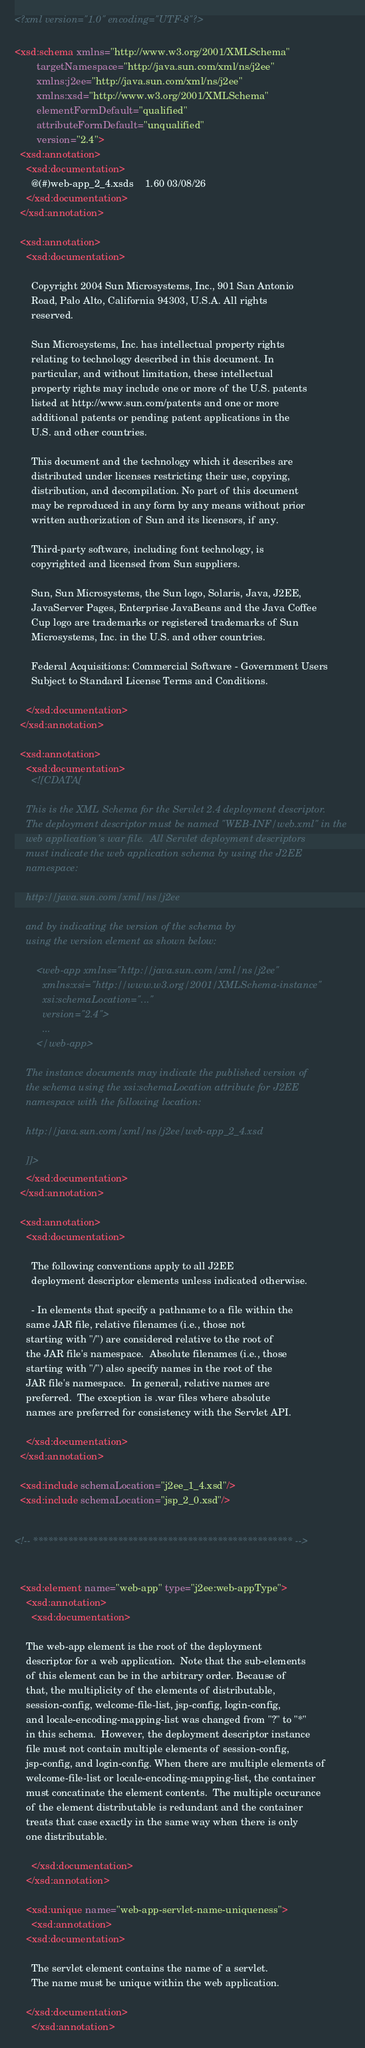<code> <loc_0><loc_0><loc_500><loc_500><_XML_><?xml version="1.0" encoding="UTF-8"?>

<xsd:schema xmlns="http://www.w3.org/2001/XMLSchema"
	    targetNamespace="http://java.sun.com/xml/ns/j2ee"
	    xmlns:j2ee="http://java.sun.com/xml/ns/j2ee"
	    xmlns:xsd="http://www.w3.org/2001/XMLSchema"
	    elementFormDefault="qualified"
	    attributeFormDefault="unqualified"
	    version="2.4">
  <xsd:annotation>
    <xsd:documentation>
      @(#)web-app_2_4.xsds	1.60 03/08/26
    </xsd:documentation>
  </xsd:annotation>

  <xsd:annotation>
    <xsd:documentation>

      Copyright 2004 Sun Microsystems, Inc., 901 San Antonio
      Road, Palo Alto, California 94303, U.S.A. All rights
      reserved.

      Sun Microsystems, Inc. has intellectual property rights
      relating to technology described in this document. In
      particular, and without limitation, these intellectual
      property rights may include one or more of the U.S. patents
      listed at http://www.sun.com/patents and one or more
      additional patents or pending patent applications in the
      U.S. and other countries.

      This document and the technology which it describes are
      distributed under licenses restricting their use, copying,
      distribution, and decompilation. No part of this document
      may be reproduced in any form by any means without prior
      written authorization of Sun and its licensors, if any.

      Third-party software, including font technology, is
      copyrighted and licensed from Sun suppliers.

      Sun, Sun Microsystems, the Sun logo, Solaris, Java, J2EE,
      JavaServer Pages, Enterprise JavaBeans and the Java Coffee
      Cup logo are trademarks or registered trademarks of Sun
      Microsystems, Inc. in the U.S. and other countries.

      Federal Acquisitions: Commercial Software - Government Users
      Subject to Standard License Terms and Conditions.

    </xsd:documentation>
  </xsd:annotation>

  <xsd:annotation>
    <xsd:documentation>
      <![CDATA[

	This is the XML Schema for the Servlet 2.4 deployment descriptor.
	The deployment descriptor must be named "WEB-INF/web.xml" in the
	web application's war file.  All Servlet deployment descriptors
	must indicate the web application schema by using the J2EE
	namespace:

	http://java.sun.com/xml/ns/j2ee

	and by indicating the version of the schema by
	using the version element as shown below:

	    <web-app xmlns="http://java.sun.com/xml/ns/j2ee"
	      xmlns:xsi="http://www.w3.org/2001/XMLSchema-instance"
	      xsi:schemaLocation="..."
	      version="2.4">
	      ...
	    </web-app>

	The instance documents may indicate the published version of
	the schema using the xsi:schemaLocation attribute for J2EE
	namespace with the following location:

	http://java.sun.com/xml/ns/j2ee/web-app_2_4.xsd

	]]>
    </xsd:documentation>
  </xsd:annotation>

  <xsd:annotation>
    <xsd:documentation>

      The following conventions apply to all J2EE
      deployment descriptor elements unless indicated otherwise.

      - In elements that specify a pathname to a file within the
	same JAR file, relative filenames (i.e., those not
	starting with "/") are considered relative to the root of
	the JAR file's namespace.  Absolute filenames (i.e., those
	starting with "/") also specify names in the root of the
	JAR file's namespace.  In general, relative names are
	preferred.  The exception is .war files where absolute
	names are preferred for consistency with the Servlet API.

    </xsd:documentation>
  </xsd:annotation>

  <xsd:include schemaLocation="j2ee_1_4.xsd"/>
  <xsd:include schemaLocation="jsp_2_0.xsd"/>


<!-- **************************************************** -->


  <xsd:element name="web-app" type="j2ee:web-appType">
    <xsd:annotation>
      <xsd:documentation>

	The web-app element is the root of the deployment
	descriptor for a web application.  Note that the sub-elements
	of this element can be in the arbitrary order. Because of
	that, the multiplicity of the elements of distributable,
	session-config, welcome-file-list, jsp-config, login-config,
	and locale-encoding-mapping-list was changed from "?" to "*"
	in this schema.  However, the deployment descriptor instance
	file must not contain multiple elements of session-config,
	jsp-config, and login-config. When there are multiple elements of
	welcome-file-list or locale-encoding-mapping-list, the container
	must concatinate the element contents.  The multiple occurance
	of the element distributable is redundant and the container
	treats that case exactly in the same way when there is only
	one distributable.

      </xsd:documentation>
    </xsd:annotation>

    <xsd:unique name="web-app-servlet-name-uniqueness">
      <xsd:annotation>
	<xsd:documentation>

	  The servlet element contains the name of a servlet.
	  The name must be unique within the web application.

	</xsd:documentation>
      </xsd:annotation></code> 